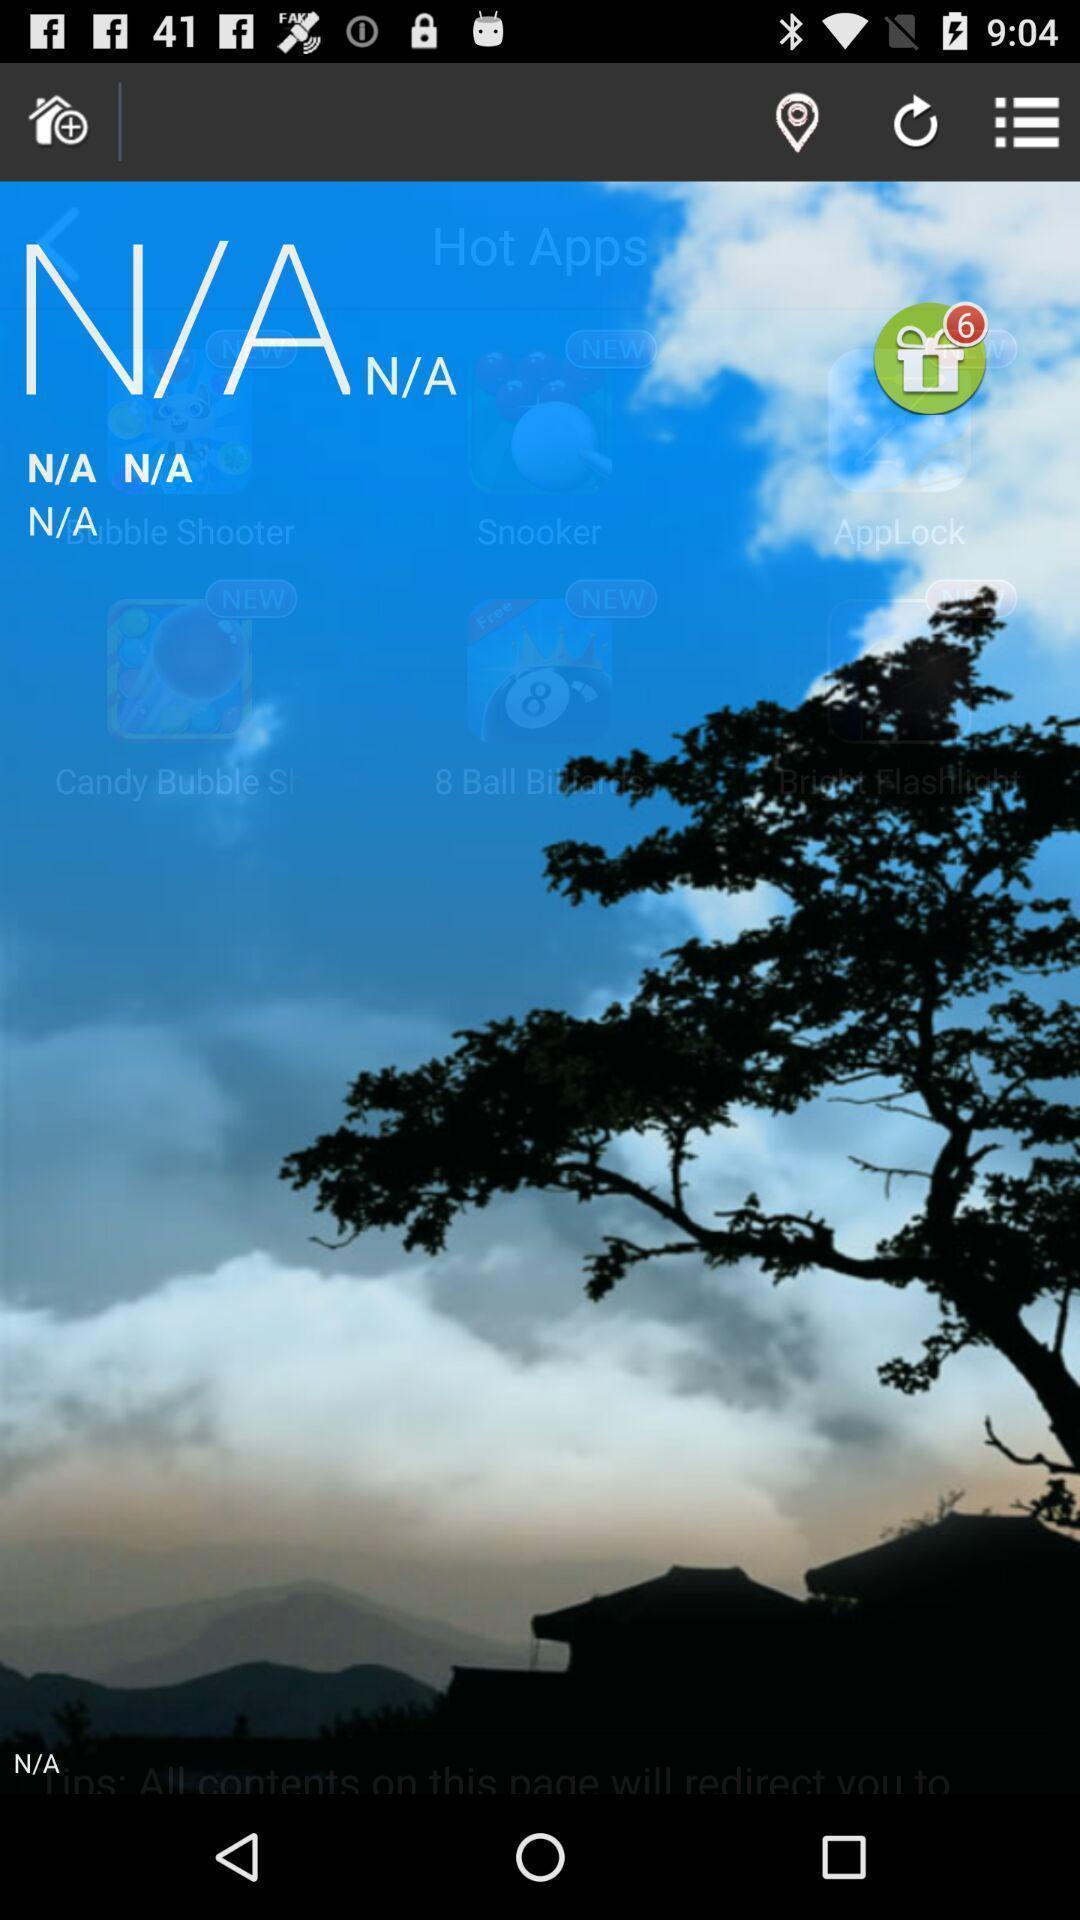Summarize the main components in this picture. Screen showing the home page of weather app. 